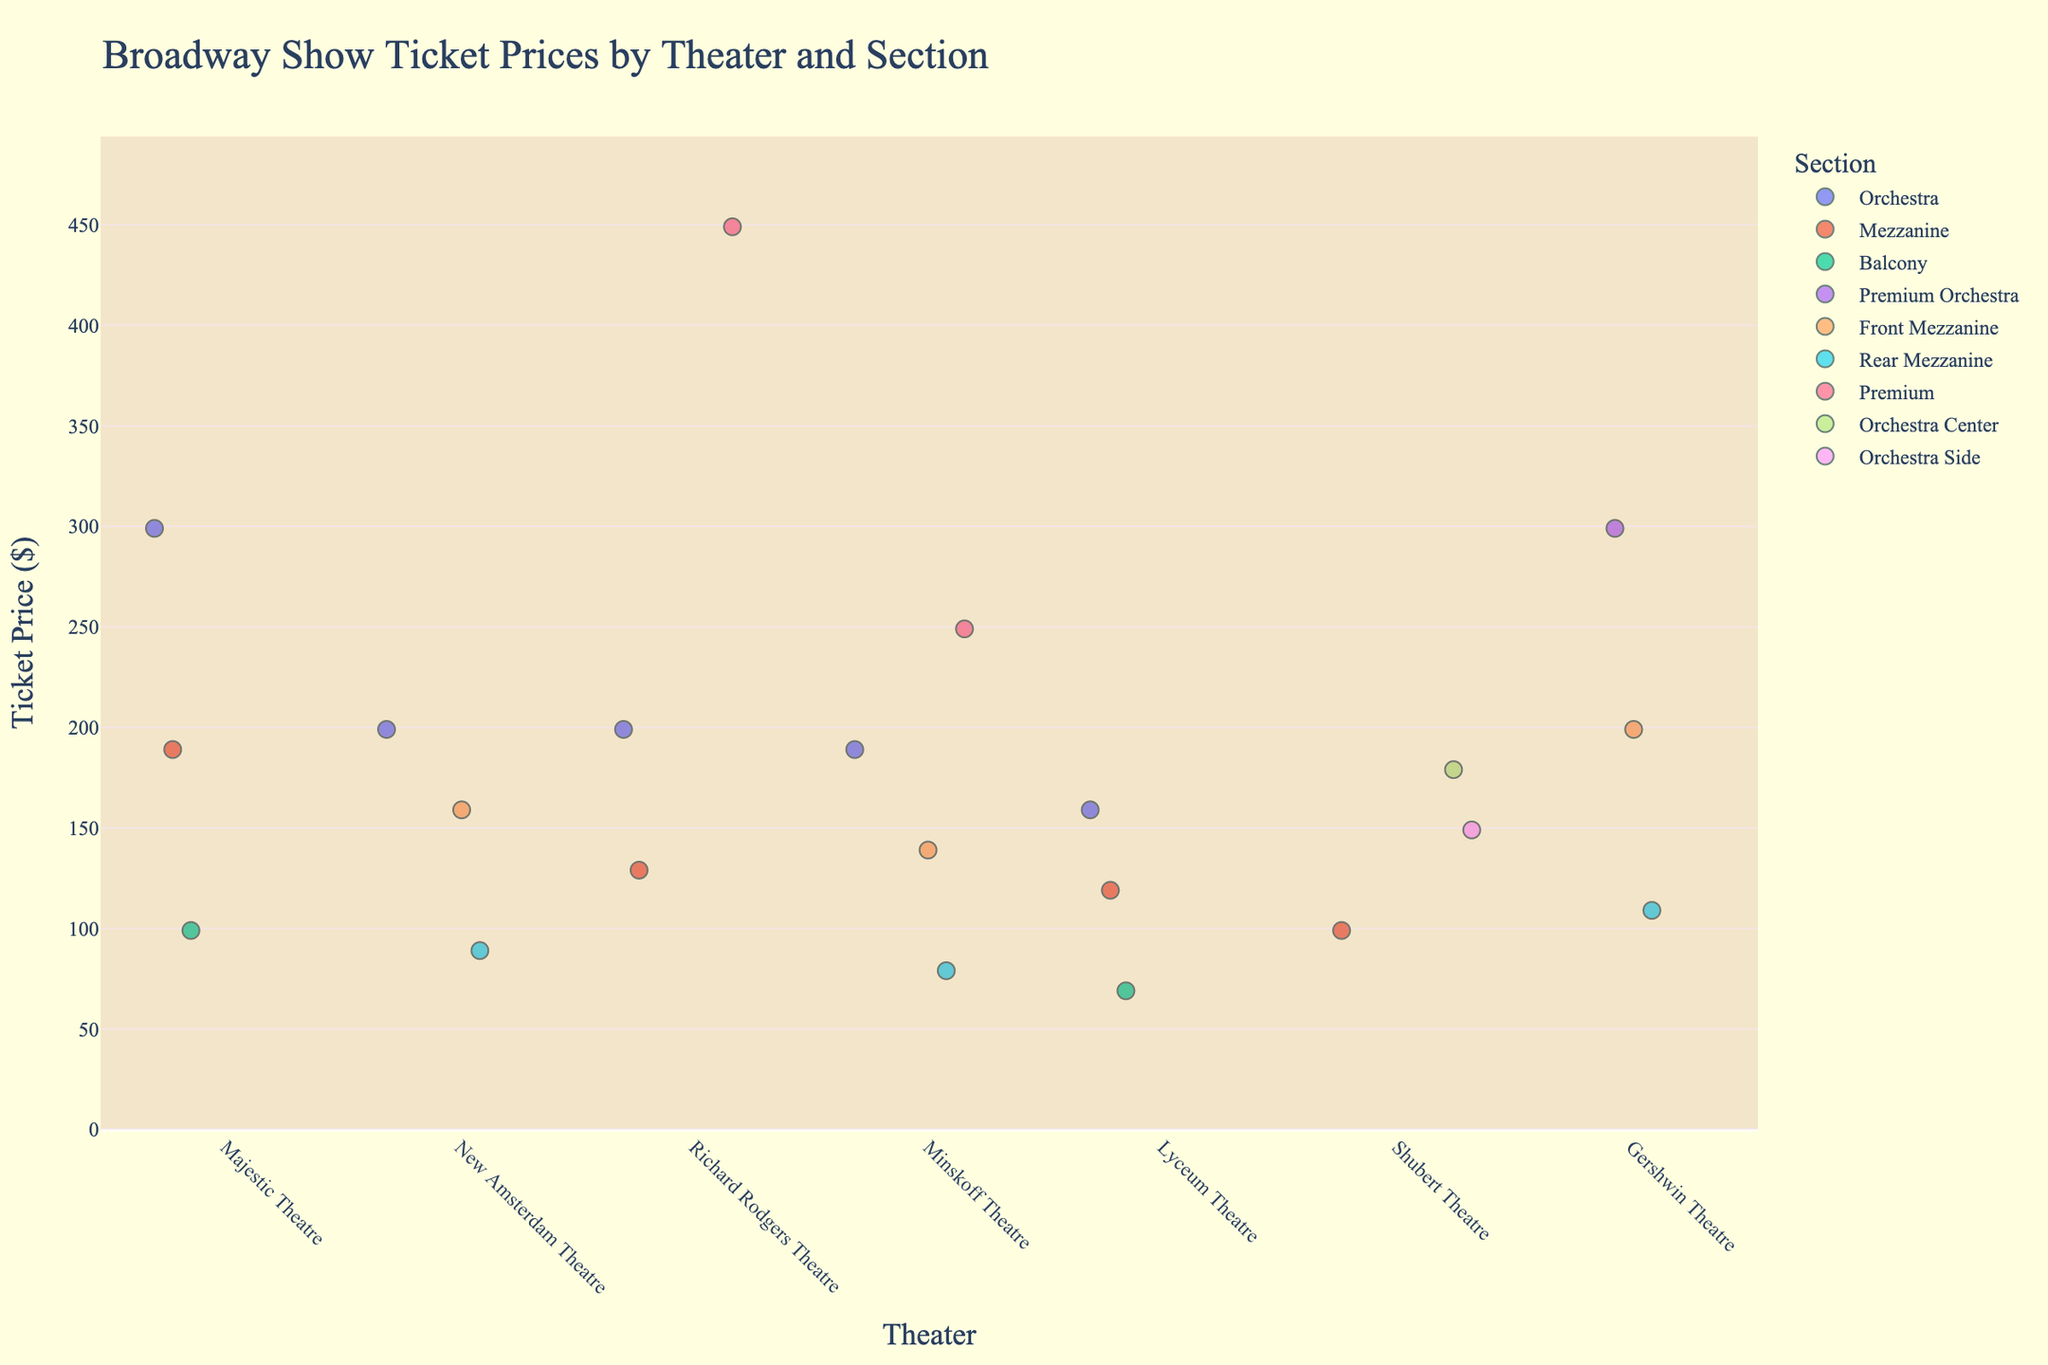Which theater has the highest ticket price and what is it? The ticket prices for each theater can be compared by identifying the highest price among all the points. The plot indicates that the Richard Rodgers Theatre has the highest ticket price, marked at $449.
Answer: Richard Rodgers Theatre, $449 Which section in the Gershwin Theatre has the lowest ticket price? By inspecting the different sections for the Gershwin Theatre displayed on the x-axis, the lowest ticket price is marked at $109 for the Rear Mezzanine.
Answer: Rear Mezzanine What is the range of ticket prices in the Majestic Theatre? To find the range, subtract the lowest ticket price in the Majestic Theatre from the highest. The lowest price is $99 (Balcony), and the highest is $299 (Orchestra), so the range is $299 - $99 = $200.
Answer: $200 Which theaters offer a ticket price of $199 for an orchestra section? By locating the points marked $199 and checking their sections, it is clear that the New Amsterdam Theatre and Richard Rodgers Theatre offer orchestra tickets for $199.
Answer: New Amsterdam Theatre, Richard Rodgers Theatre Are there any theaters where the orchestra section is cheaper than the premium sections of the same or other theaters? Comparing orchestra and premium ticket prices, you'll see the orchestra section in multiple theaters (e.g., Shubert Theatre at $179) is cheaper than premium sections like Richard Rodgers Theatre's Premium at $449.
Answer: Yes Which theater offers the most affordable ticket and how much is it? By identifying the lowest point on the y-axis, the most affordable ticket price is found at the Lyceum Theatre for the Balcony section at $69.
Answer: Lyceum Theatre, $69 How do ticket prices in the Mezzanine section of the Richard Rodgers Theatre compare to the Balcony section of the Lyceum Theatre? The Mezzanine section in the Richard Rodgers Theatre is priced at $129, whereas the Balcony section of the Lyceum Theatre is much cheaper at $69.
Answer: Mezzanine is more expensive What is the average price of tickets in the Orchestra section across all theaters? Summing up the ticket prices for the Orchestra section across all theaters and dividing by the number of data points: ($299 + $199 + $179 + $189 + $159) / 5 = $205.
Answer: $205 Which theater has the most varied ticket pricing (i.e., the largest range)? By determining the range of ticket prices for each theater and identifying the largest: Richard Rodgers Theatre ranges from $129 to $449, yielding a range of $320, which is the largest.
Answer: Richard Rodgers Theatre Are there any theaters where all section ticket prices are below $200? Check each theater and validate their section prices: Lyceum Theatre ($69 - $159) and Shubert Theatre ($99 - $179) both have prices under $200 for all sections.
Answer: Yes 